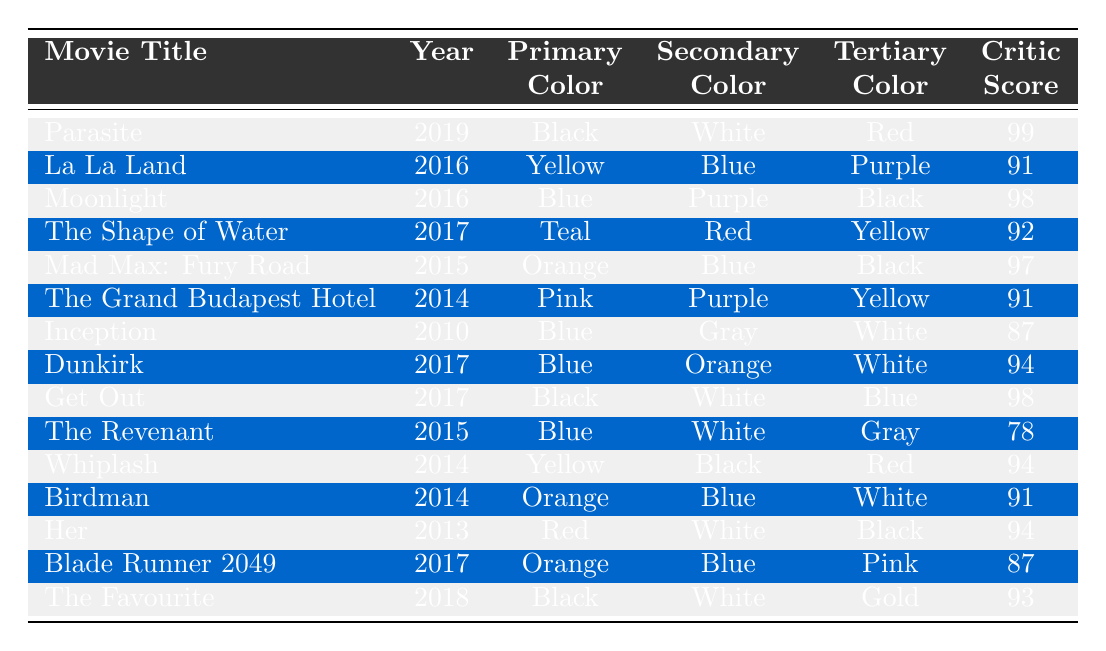What is the primary color of the movie "Get Out"? The primary color listed for "Get Out" in the table is Black.
Answer: Black Which movie has the highest critic score? Referring to the table, "Parasite" has the highest critic score of 99.
Answer: Parasite How many movies have Blue as their primary color? The table lists the following movies with Blue as the primary color: "Moonlight," "Inception," "Dunkirk," and "The Revenant." That's a total of 4 movies.
Answer: 4 What is the secondary color of "La La Land"? The secondary color for "La La Land" in the table is Blue.
Answer: Blue Which movie released in 2015 has the color Orange as the primary color? The movies released in 2015 with Orange as the primary color are "Mad Max: Fury Road" and "Birdman."
Answer: Mad Max: Fury Road, Birdman What is the average critic score of the movies with Black as the primary color? The movies with Black as the primary color are "Parasite," "Get Out," and "The Favourite," with scores of 99, 98, and 93, respectively. The average is calculated as (99 + 98 + 93) / 3 = 96.67, which rounds to 97.
Answer: 97 Is "The Shape of Water" a movie from 2018? The table shows that "The Shape of Water" was released in 2017, not 2018.
Answer: No Which movie has both Orange and Blue in its color palette? The movies containing both Orange and Blue are "Mad Max: Fury Road," "Dunkirk," and "Blade Runner 2049."
Answer: 3 What is the tertiary color of "The Grand Budapest Hotel"? According to the table, the tertiary color for "The Grand Budapest Hotel" is Yellow.
Answer: Yellow How many movies have a critic score greater than 90? By checking the table, the movies with a score greater than 90 are "Parasite," "Moonlight," "The Shape of Water," "Mad Max: Fury Road," "Dunkirk," "Get Out," "Whiplash," "Birdman," "Her," "The Favourite." That totals 10 movies.
Answer: 10 Which movie's colors include Gold? The only movie that includes Gold in its color palette is "The Favourite."
Answer: The Favourite 